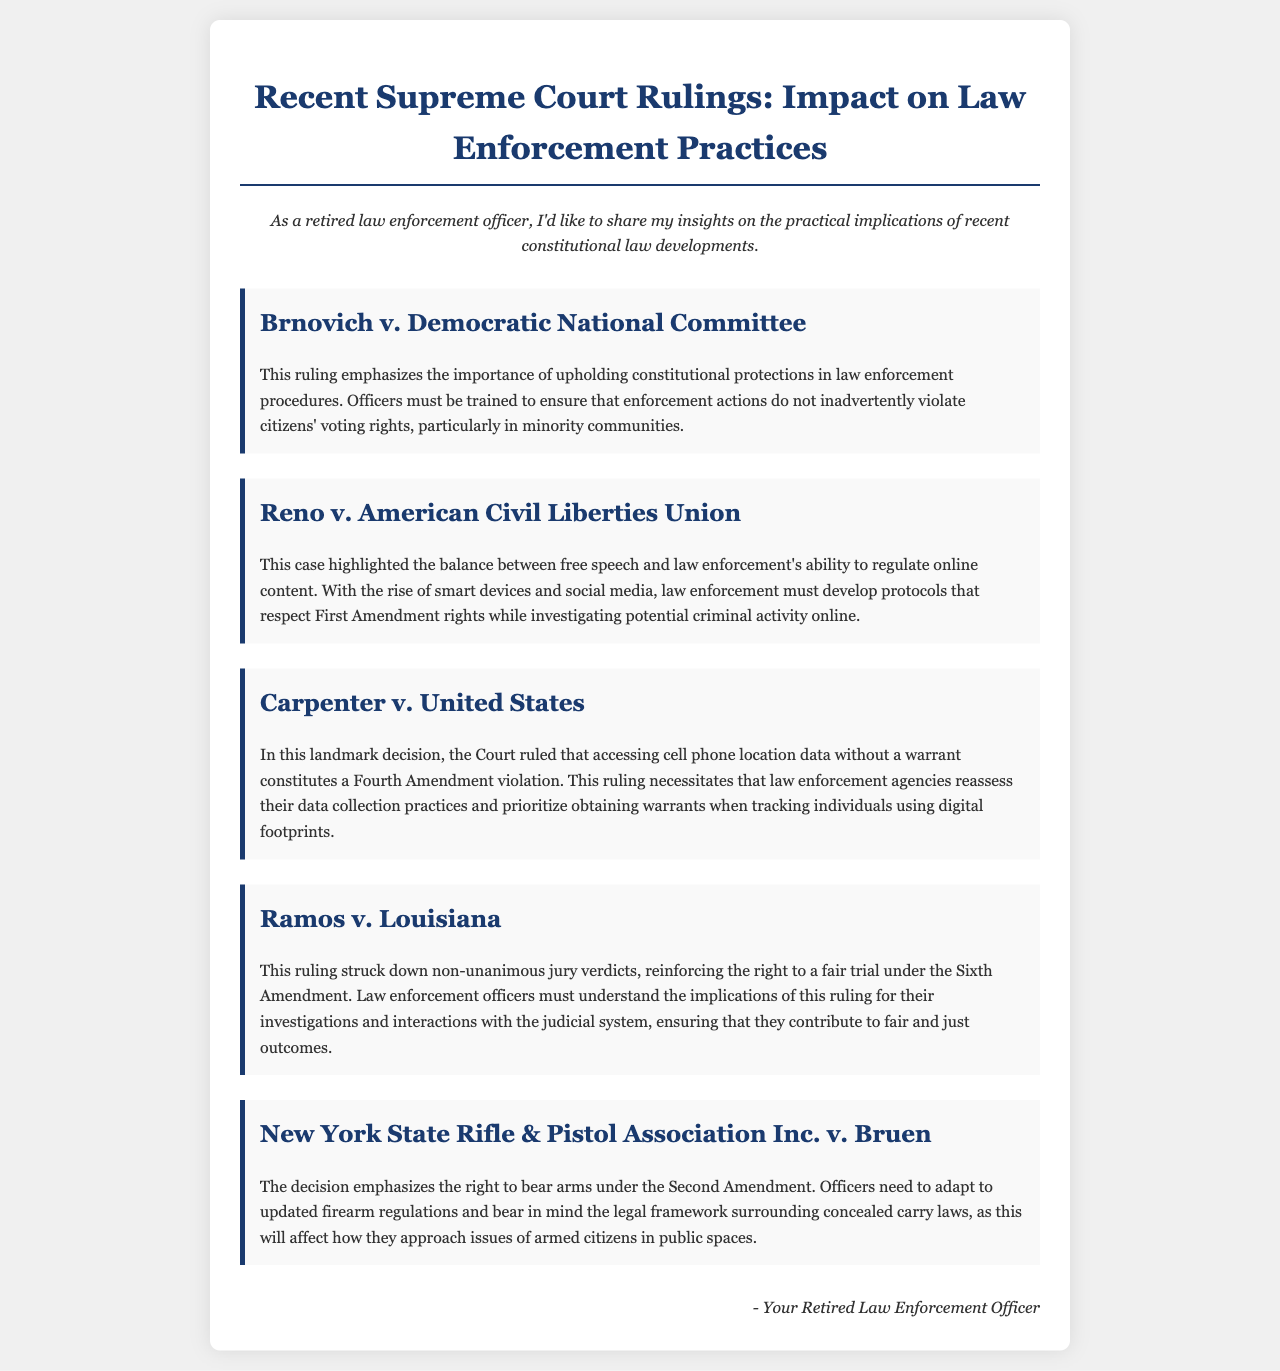What is the title of the document? The title is prominently displayed at the top of the document.
Answer: Recent Supreme Court Rulings: Impact on Law Enforcement Practices Which case addresses the importance of voting rights? The document lists several cases, one specifically refers to voting rights.
Answer: Brnovich v. Democratic National Committee What ruling requires a warrant for accessing cell phone location data? The content explains a significant decision regarding digital privacy and warrants.
Answer: Carpenter v. United States What amendment is reinforced by Ramos v. Louisiana? This case is specifically linked to a constitutional amendment related to legal proceedings.
Answer: Sixth Amendment What is the primary focus of New York State Rifle & Pistol Association Inc. v. Bruen? The case is centered around a particular constitutional right mentioned explicitly.
Answer: Right to bear arms How must law enforcement adapt according to Reno v. American Civil Liberties Union? The document explains a necessary adjustment that law enforcement needs to make in relation to constitutional rights.
Answer: Develop protocols that respect First Amendment rights 